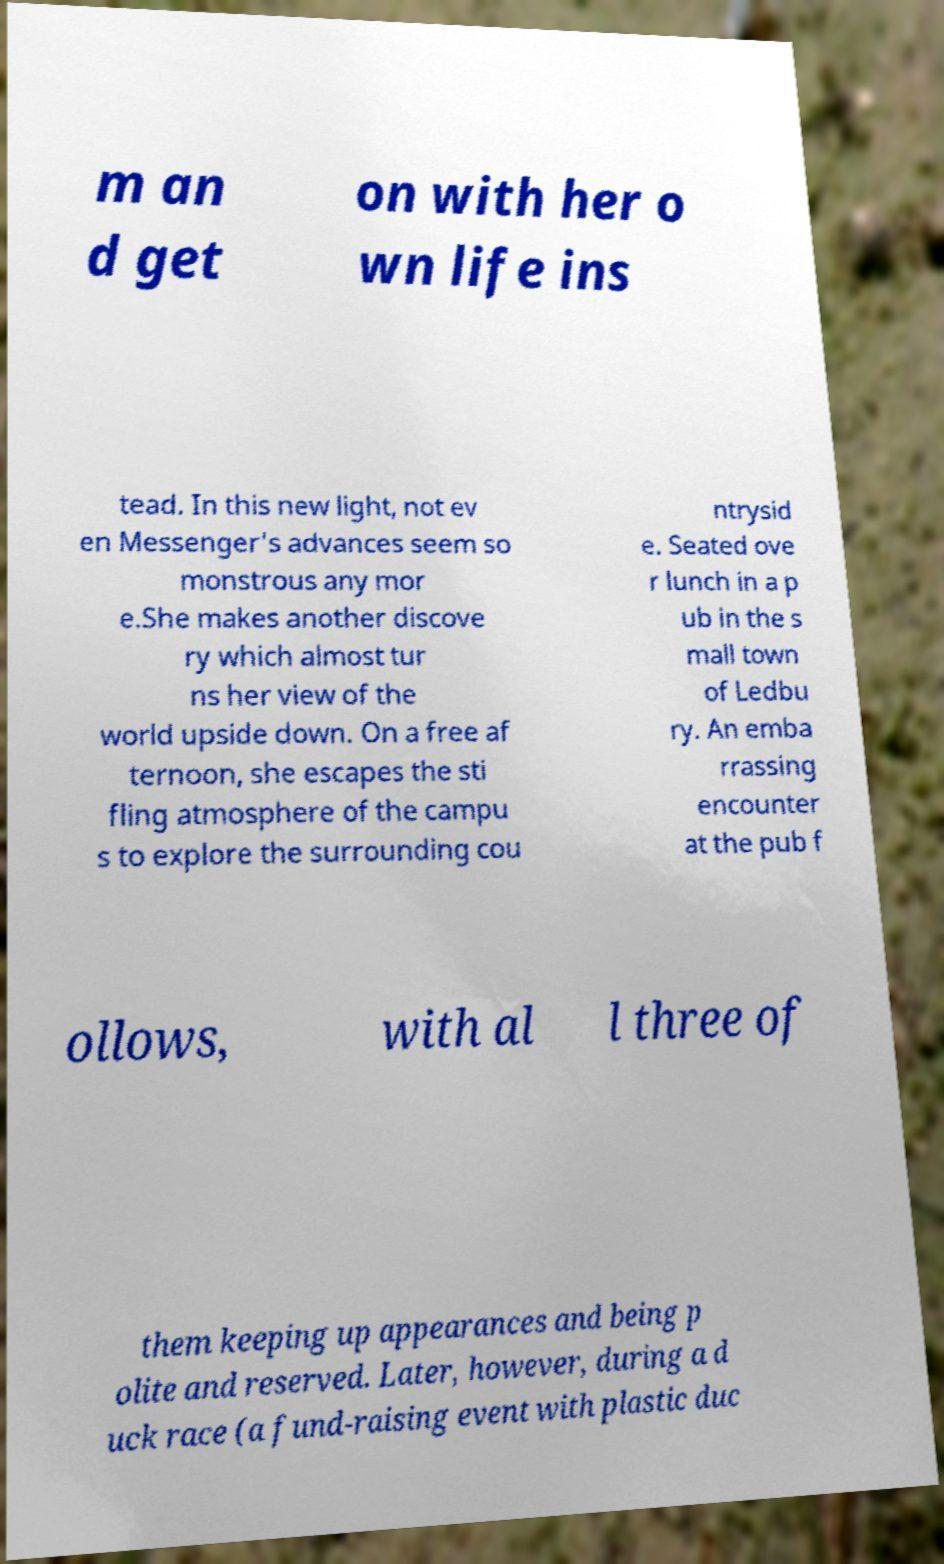Can you read and provide the text displayed in the image?This photo seems to have some interesting text. Can you extract and type it out for me? m an d get on with her o wn life ins tead. In this new light, not ev en Messenger's advances seem so monstrous any mor e.She makes another discove ry which almost tur ns her view of the world upside down. On a free af ternoon, she escapes the sti fling atmosphere of the campu s to explore the surrounding cou ntrysid e. Seated ove r lunch in a p ub in the s mall town of Ledbu ry. An emba rrassing encounter at the pub f ollows, with al l three of them keeping up appearances and being p olite and reserved. Later, however, during a d uck race (a fund-raising event with plastic duc 